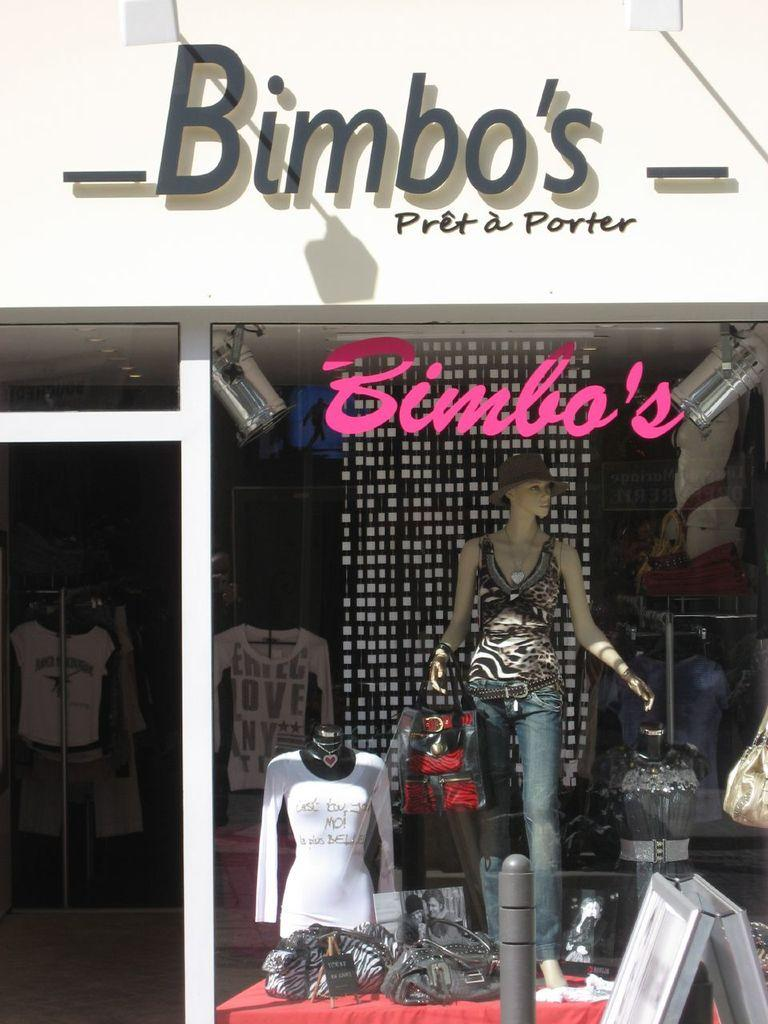<image>
Give a short and clear explanation of the subsequent image. a store with the word Bimbos at the top of it 